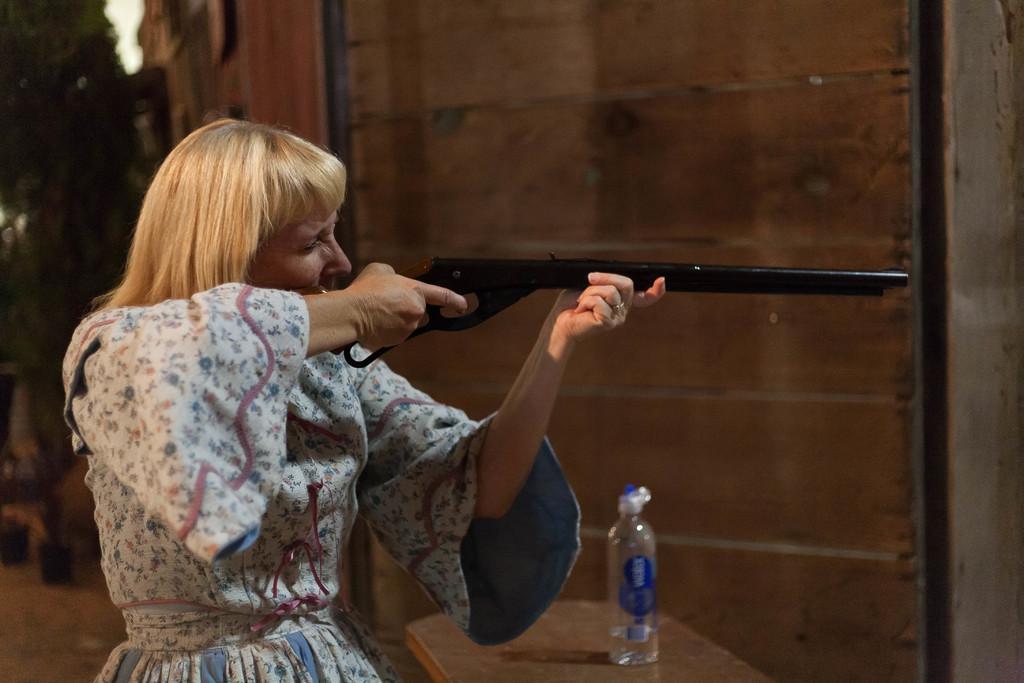How would you summarize this image in a sentence or two? In this image there is a woman holding a gun is aiming at something, in front of the woman there is a bottle of water on the table. 